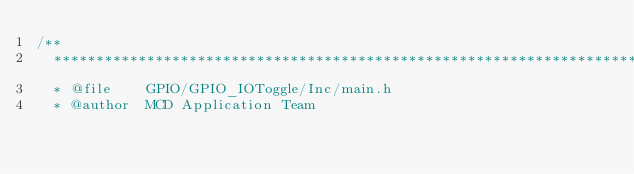Convert code to text. <code><loc_0><loc_0><loc_500><loc_500><_C_>/**
  ******************************************************************************
  * @file    GPIO/GPIO_IOToggle/Inc/main.h 
  * @author  MCD Application Team</code> 